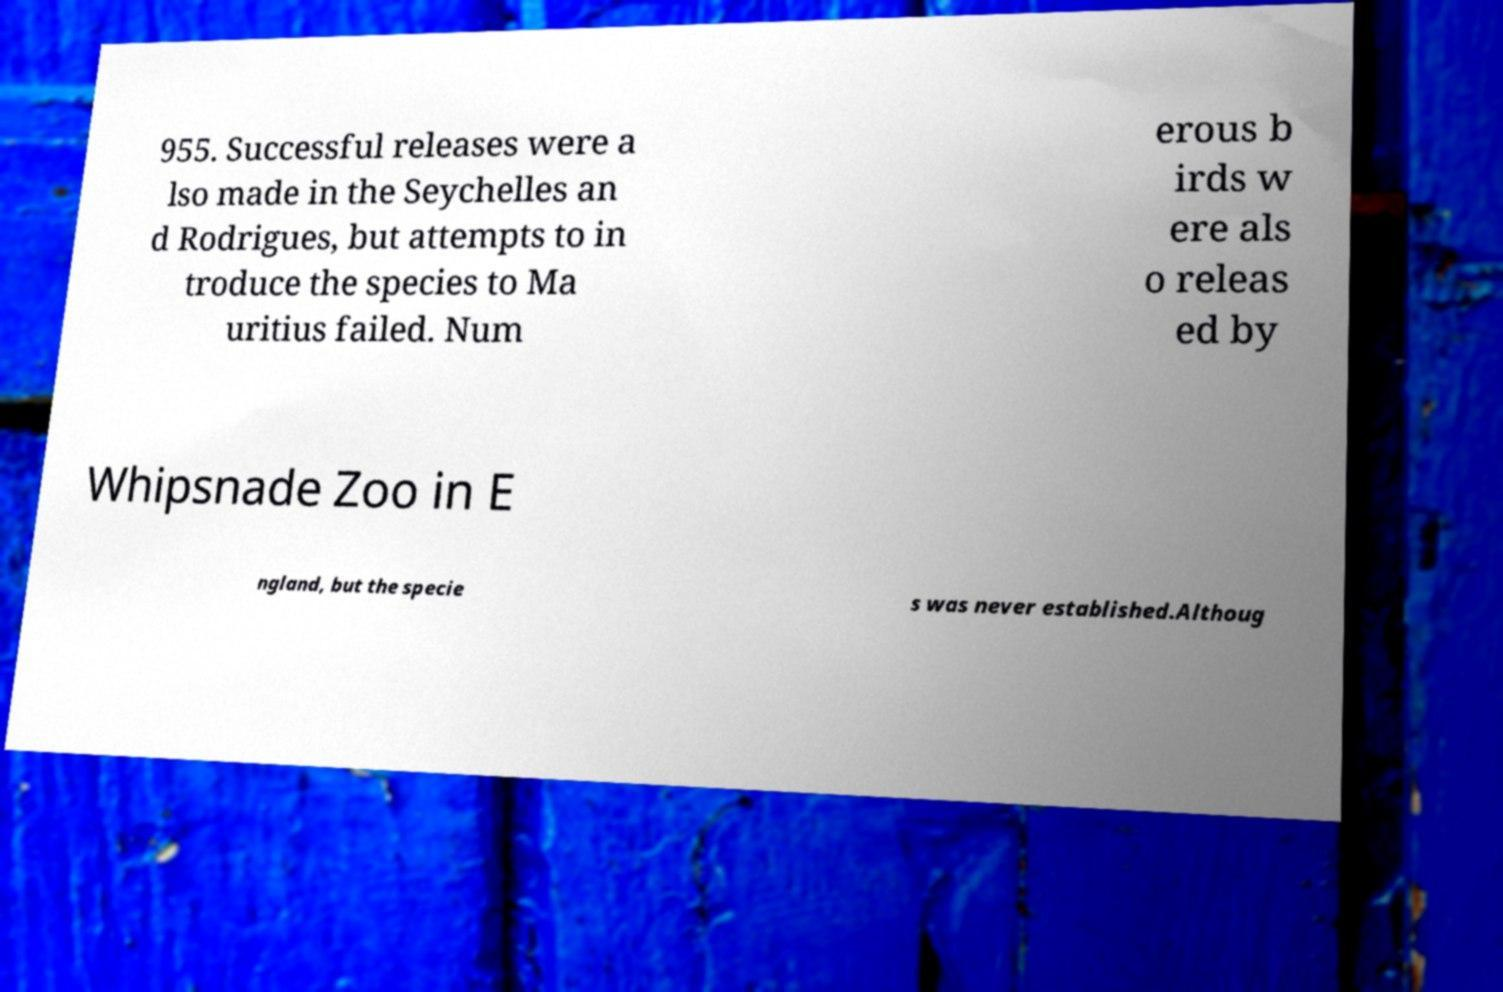I need the written content from this picture converted into text. Can you do that? 955. Successful releases were a lso made in the Seychelles an d Rodrigues, but attempts to in troduce the species to Ma uritius failed. Num erous b irds w ere als o releas ed by Whipsnade Zoo in E ngland, but the specie s was never established.Althoug 